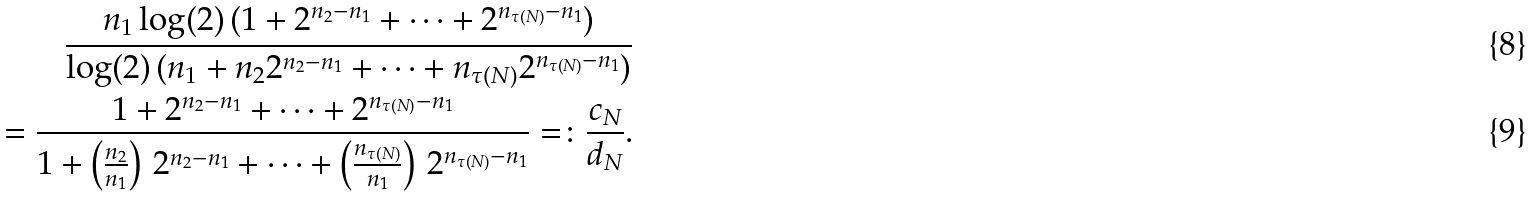<formula> <loc_0><loc_0><loc_500><loc_500>\frac { n _ { 1 } \log ( 2 ) \, ( 1 + 2 ^ { n _ { 2 } - n _ { 1 } } + \cdots + 2 ^ { n _ { \tau ( N ) } - n _ { 1 } } ) } { \log ( 2 ) \, ( n _ { 1 } + n _ { 2 } 2 ^ { n _ { 2 } - n _ { 1 } } + \cdots + n _ { \tau ( N ) } 2 ^ { n _ { \tau ( N ) } - n _ { 1 } } ) } \\ = \frac { 1 + 2 ^ { n _ { 2 } - n _ { 1 } } + \cdots + 2 ^ { n _ { \tau ( N ) } - n _ { 1 } } } { 1 + \left ( \frac { n _ { 2 } } { n _ { 1 } } \right ) \, 2 ^ { n _ { 2 } - n _ { 1 } } + \cdots + \left ( \frac { n _ { \tau ( N ) } } { n _ { 1 } } \right ) \, 2 ^ { n _ { \tau ( N ) } - n _ { 1 } } } = \colon \frac { c _ { N } } { d _ { N } } .</formula> 